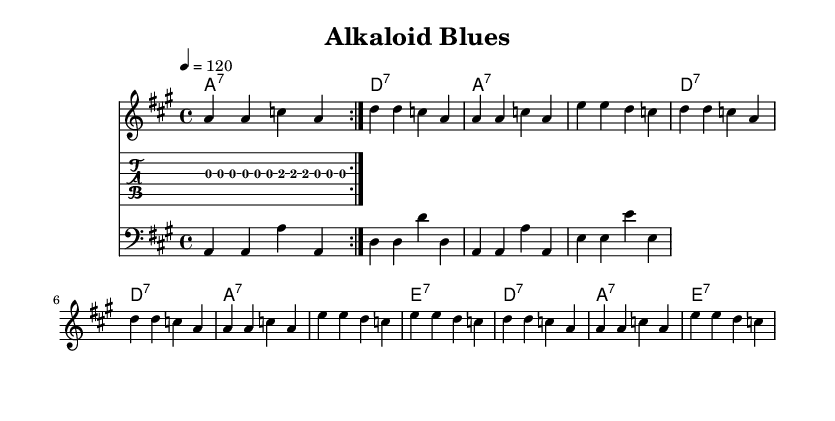What is the key signature of this music? The key signature is A major, which has three sharps (F#, C#, and G#). It is indicated at the beginning of the staff on the left side.
Answer: A major What is the time signature of this piece? The time signature is indicated at the beginning as 4/4, meaning there are four beats per measure and the quarter note gets one beat.
Answer: 4/4 What is the tempo marking for this composition? The tempo marking indicates a speed of 120 beats per minute, found at the beginning, under the title.
Answer: 120 How many bars are in the first verse? The first verse consists of four measures, as counted from the measure lines shown in the notation.
Answer: Four What type of chords are predominantly used in the harmonies? The harmonies feature seventh chords, as evidenced by the notation of major chords followed by a 7 in the chord symbols.
Answer: Seventh chords What musical form does this piece follow? The piece follows a 12-bar blues form, which is characteristic of the structure seen in the repeating chord patterns throughout the music.
Answer: 12-bar blues What instruments are used in this composition? The composition includes a melody staff, a guitar tab staff, and a bass staff, indicating that a vocal line, guitar, and bass are featured.
Answer: Vocal, guitar, bass 